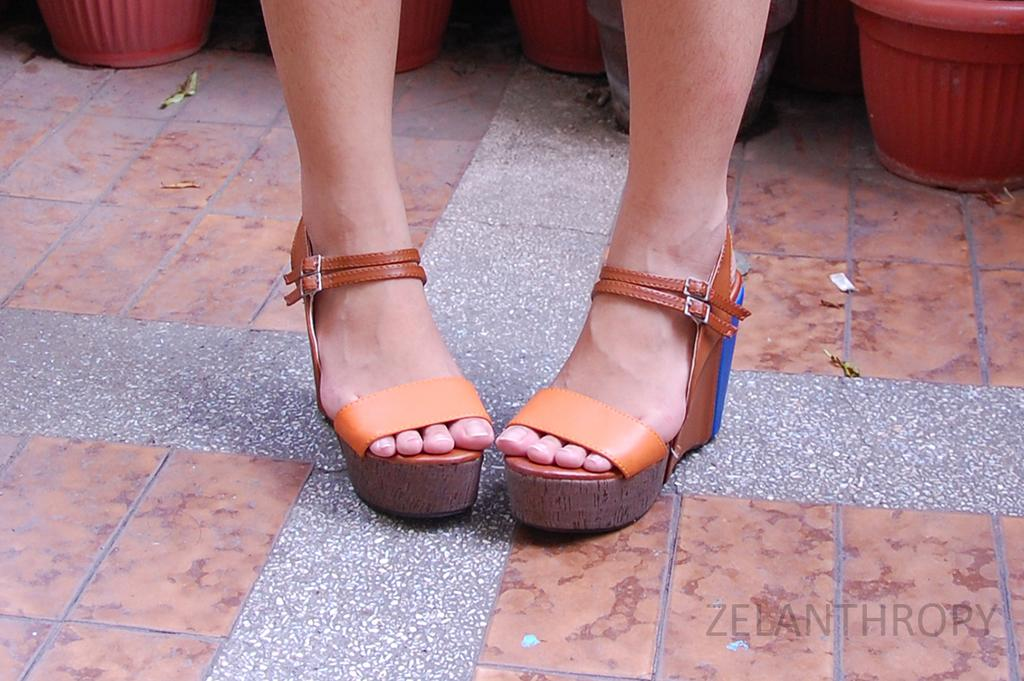What body parts are visible in the image? There are two legs visible in the image. What is covering the legs in the image? Footwear is present on the legs. What can be seen behind the legs in the image? There are flower pots behind the legs. What type of hair can be seen on the legs in the image? There is no hair visible on the legs in the image. What time of day is depicted in the image? The time of day cannot be determined from the image, as there are no clues about the lighting or time-related elements. 